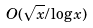Convert formula to latex. <formula><loc_0><loc_0><loc_500><loc_500>O ( \sqrt { x } / \log x )</formula> 